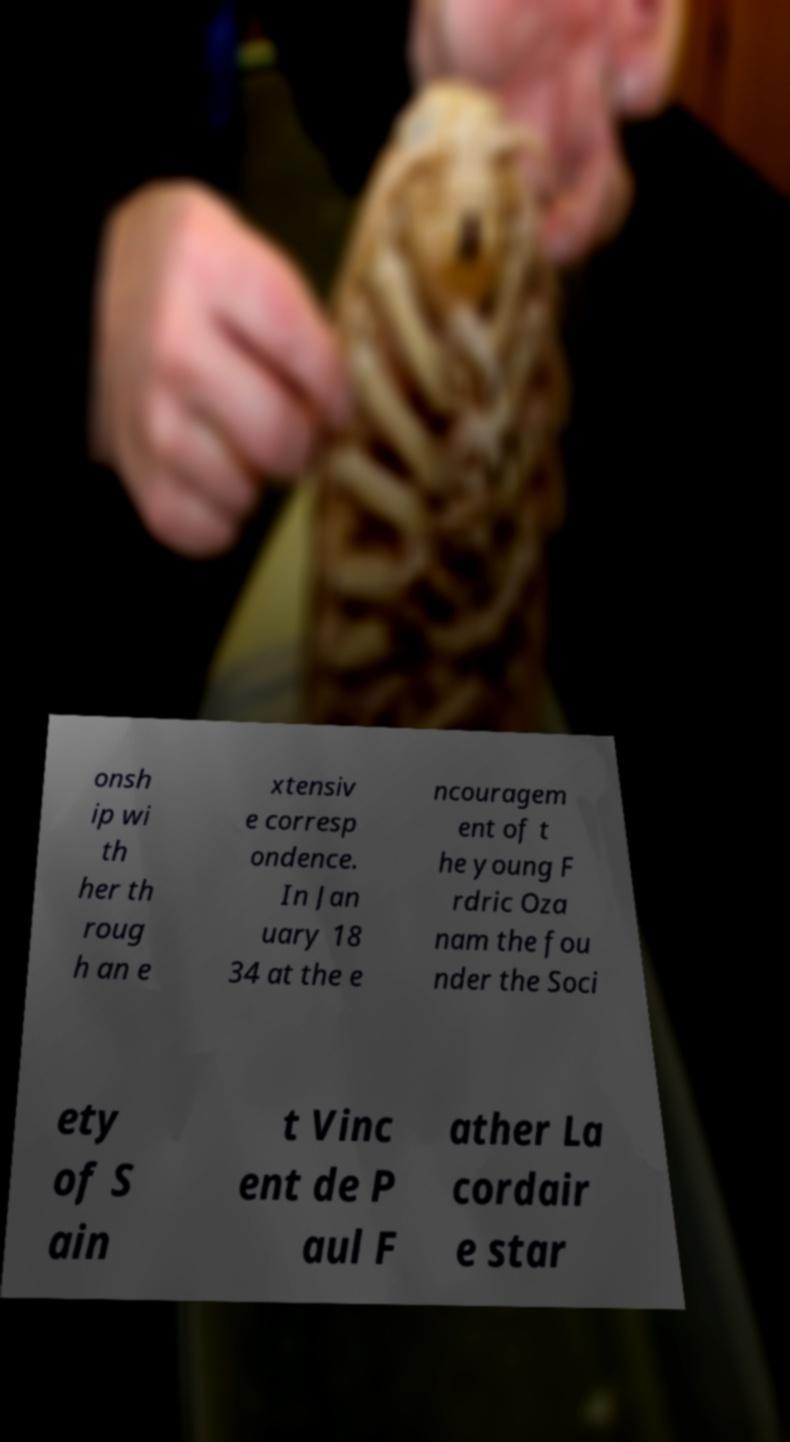Please read and relay the text visible in this image. What does it say? onsh ip wi th her th roug h an e xtensiv e corresp ondence. In Jan uary 18 34 at the e ncouragem ent of t he young F rdric Oza nam the fou nder the Soci ety of S ain t Vinc ent de P aul F ather La cordair e star 